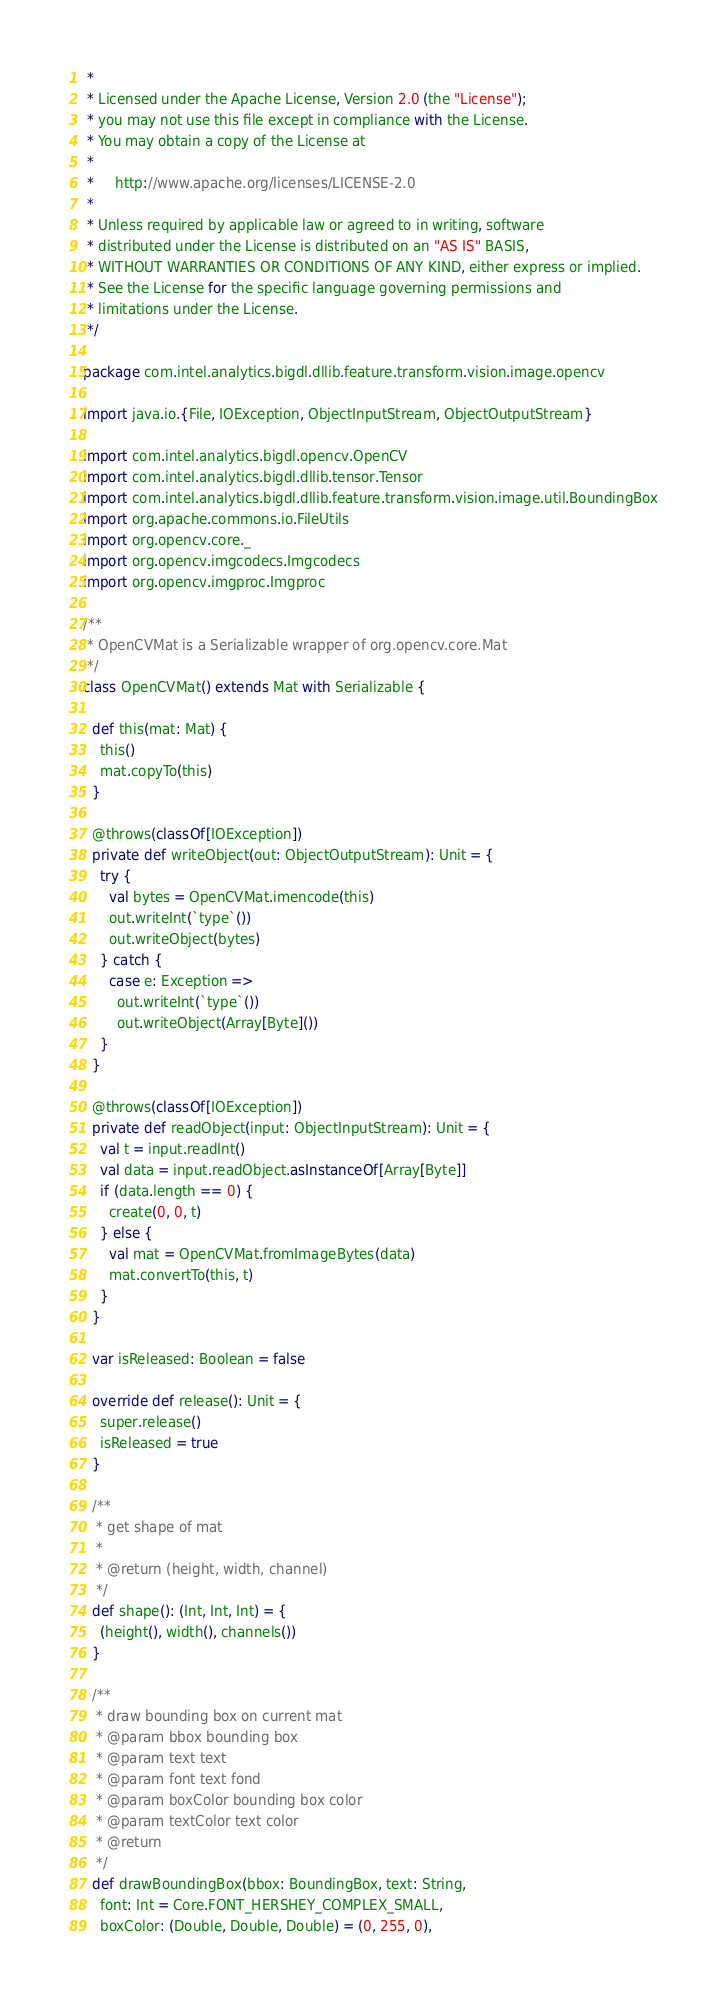Convert code to text. <code><loc_0><loc_0><loc_500><loc_500><_Scala_> *
 * Licensed under the Apache License, Version 2.0 (the "License");
 * you may not use this file except in compliance with the License.
 * You may obtain a copy of the License at
 *
 *     http://www.apache.org/licenses/LICENSE-2.0
 *
 * Unless required by applicable law or agreed to in writing, software
 * distributed under the License is distributed on an "AS IS" BASIS,
 * WITHOUT WARRANTIES OR CONDITIONS OF ANY KIND, either express or implied.
 * See the License for the specific language governing permissions and
 * limitations under the License.
 */

package com.intel.analytics.bigdl.dllib.feature.transform.vision.image.opencv

import java.io.{File, IOException, ObjectInputStream, ObjectOutputStream}

import com.intel.analytics.bigdl.opencv.OpenCV
import com.intel.analytics.bigdl.dllib.tensor.Tensor
import com.intel.analytics.bigdl.dllib.feature.transform.vision.image.util.BoundingBox
import org.apache.commons.io.FileUtils
import org.opencv.core._
import org.opencv.imgcodecs.Imgcodecs
import org.opencv.imgproc.Imgproc

/**
 * OpenCVMat is a Serializable wrapper of org.opencv.core.Mat
 */
class OpenCVMat() extends Mat with Serializable {

  def this(mat: Mat) {
    this()
    mat.copyTo(this)
  }

  @throws(classOf[IOException])
  private def writeObject(out: ObjectOutputStream): Unit = {
    try {
      val bytes = OpenCVMat.imencode(this)
      out.writeInt(`type`())
      out.writeObject(bytes)
    } catch {
      case e: Exception =>
        out.writeInt(`type`())
        out.writeObject(Array[Byte]())
    }
  }

  @throws(classOf[IOException])
  private def readObject(input: ObjectInputStream): Unit = {
    val t = input.readInt()
    val data = input.readObject.asInstanceOf[Array[Byte]]
    if (data.length == 0) {
      create(0, 0, t)
    } else {
      val mat = OpenCVMat.fromImageBytes(data)
      mat.convertTo(this, t)
    }
  }

  var isReleased: Boolean = false

  override def release(): Unit = {
    super.release()
    isReleased = true
  }

  /**
   * get shape of mat
   *
   * @return (height, width, channel)
   */
  def shape(): (Int, Int, Int) = {
    (height(), width(), channels())
  }

  /**
   * draw bounding box on current mat
   * @param bbox bounding box
   * @param text text
   * @param font text fond
   * @param boxColor bounding box color
   * @param textColor text color
   * @return
   */
  def drawBoundingBox(bbox: BoundingBox, text: String,
    font: Int = Core.FONT_HERSHEY_COMPLEX_SMALL,
    boxColor: (Double, Double, Double) = (0, 255, 0),</code> 